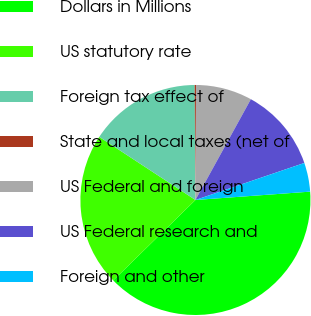<chart> <loc_0><loc_0><loc_500><loc_500><pie_chart><fcel>Dollars in Millions<fcel>US statutory rate<fcel>Foreign tax effect of<fcel>State and local taxes (net of<fcel>US Federal and foreign<fcel>US Federal research and<fcel>Foreign and other<nl><fcel>38.83%<fcel>21.57%<fcel>15.65%<fcel>0.19%<fcel>7.92%<fcel>11.78%<fcel>4.06%<nl></chart> 